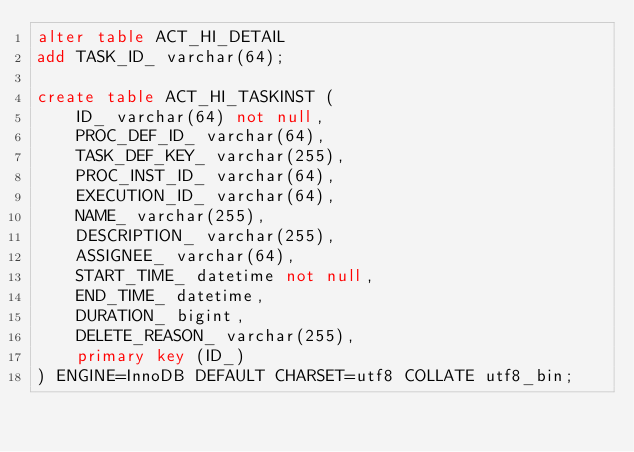<code> <loc_0><loc_0><loc_500><loc_500><_SQL_>alter table ACT_HI_DETAIL
add TASK_ID_ varchar(64);

create table ACT_HI_TASKINST (
    ID_ varchar(64) not null,
    PROC_DEF_ID_ varchar(64),
    TASK_DEF_KEY_ varchar(255),
    PROC_INST_ID_ varchar(64),
    EXECUTION_ID_ varchar(64),
    NAME_ varchar(255),
    DESCRIPTION_ varchar(255),
    ASSIGNEE_ varchar(64),
    START_TIME_ datetime not null,
    END_TIME_ datetime,
    DURATION_ bigint,
    DELETE_REASON_ varchar(255),
    primary key (ID_)
) ENGINE=InnoDB DEFAULT CHARSET=utf8 COLLATE utf8_bin;
</code> 